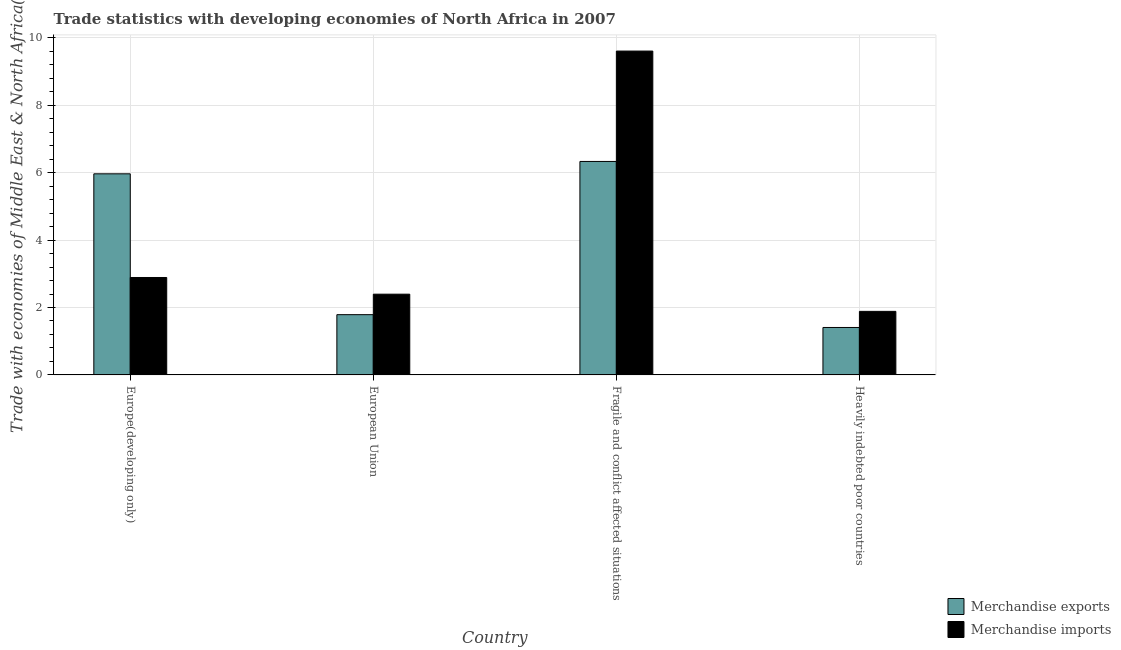How many bars are there on the 1st tick from the right?
Your answer should be compact. 2. What is the label of the 4th group of bars from the left?
Your answer should be very brief. Heavily indebted poor countries. What is the merchandise exports in European Union?
Provide a short and direct response. 1.79. Across all countries, what is the maximum merchandise imports?
Ensure brevity in your answer.  9.61. Across all countries, what is the minimum merchandise exports?
Offer a terse response. 1.41. In which country was the merchandise exports maximum?
Provide a short and direct response. Fragile and conflict affected situations. In which country was the merchandise exports minimum?
Your answer should be very brief. Heavily indebted poor countries. What is the total merchandise exports in the graph?
Offer a very short reply. 15.49. What is the difference between the merchandise exports in European Union and that in Heavily indebted poor countries?
Ensure brevity in your answer.  0.38. What is the difference between the merchandise exports in European Union and the merchandise imports in Fragile and conflict affected situations?
Give a very brief answer. -7.82. What is the average merchandise exports per country?
Your answer should be compact. 3.87. What is the difference between the merchandise imports and merchandise exports in European Union?
Offer a terse response. 0.61. In how many countries, is the merchandise imports greater than 3.2 %?
Your answer should be compact. 1. What is the ratio of the merchandise exports in European Union to that in Fragile and conflict affected situations?
Ensure brevity in your answer.  0.28. Is the difference between the merchandise imports in Europe(developing only) and Heavily indebted poor countries greater than the difference between the merchandise exports in Europe(developing only) and Heavily indebted poor countries?
Your answer should be compact. No. What is the difference between the highest and the second highest merchandise imports?
Your answer should be very brief. 6.72. What is the difference between the highest and the lowest merchandise exports?
Provide a short and direct response. 4.93. What does the 1st bar from the left in European Union represents?
Provide a succinct answer. Merchandise exports. Are all the bars in the graph horizontal?
Ensure brevity in your answer.  No. How many countries are there in the graph?
Give a very brief answer. 4. What is the difference between two consecutive major ticks on the Y-axis?
Your answer should be very brief. 2. Are the values on the major ticks of Y-axis written in scientific E-notation?
Provide a short and direct response. No. Does the graph contain grids?
Offer a terse response. Yes. Where does the legend appear in the graph?
Your answer should be very brief. Bottom right. How many legend labels are there?
Make the answer very short. 2. What is the title of the graph?
Your answer should be compact. Trade statistics with developing economies of North Africa in 2007. What is the label or title of the X-axis?
Your answer should be very brief. Country. What is the label or title of the Y-axis?
Your answer should be compact. Trade with economies of Middle East & North Africa(%). What is the Trade with economies of Middle East & North Africa(%) of Merchandise exports in Europe(developing only)?
Keep it short and to the point. 5.97. What is the Trade with economies of Middle East & North Africa(%) in Merchandise imports in Europe(developing only)?
Provide a short and direct response. 2.89. What is the Trade with economies of Middle East & North Africa(%) of Merchandise exports in European Union?
Offer a very short reply. 1.79. What is the Trade with economies of Middle East & North Africa(%) of Merchandise imports in European Union?
Your response must be concise. 2.4. What is the Trade with economies of Middle East & North Africa(%) of Merchandise exports in Fragile and conflict affected situations?
Your answer should be compact. 6.33. What is the Trade with economies of Middle East & North Africa(%) in Merchandise imports in Fragile and conflict affected situations?
Your response must be concise. 9.61. What is the Trade with economies of Middle East & North Africa(%) of Merchandise exports in Heavily indebted poor countries?
Give a very brief answer. 1.41. What is the Trade with economies of Middle East & North Africa(%) of Merchandise imports in Heavily indebted poor countries?
Keep it short and to the point. 1.89. Across all countries, what is the maximum Trade with economies of Middle East & North Africa(%) in Merchandise exports?
Make the answer very short. 6.33. Across all countries, what is the maximum Trade with economies of Middle East & North Africa(%) in Merchandise imports?
Provide a short and direct response. 9.61. Across all countries, what is the minimum Trade with economies of Middle East & North Africa(%) in Merchandise exports?
Keep it short and to the point. 1.41. Across all countries, what is the minimum Trade with economies of Middle East & North Africa(%) in Merchandise imports?
Give a very brief answer. 1.89. What is the total Trade with economies of Middle East & North Africa(%) of Merchandise exports in the graph?
Ensure brevity in your answer.  15.49. What is the total Trade with economies of Middle East & North Africa(%) in Merchandise imports in the graph?
Your answer should be very brief. 16.78. What is the difference between the Trade with economies of Middle East & North Africa(%) of Merchandise exports in Europe(developing only) and that in European Union?
Provide a short and direct response. 4.18. What is the difference between the Trade with economies of Middle East & North Africa(%) in Merchandise imports in Europe(developing only) and that in European Union?
Keep it short and to the point. 0.49. What is the difference between the Trade with economies of Middle East & North Africa(%) in Merchandise exports in Europe(developing only) and that in Fragile and conflict affected situations?
Provide a succinct answer. -0.37. What is the difference between the Trade with economies of Middle East & North Africa(%) of Merchandise imports in Europe(developing only) and that in Fragile and conflict affected situations?
Your response must be concise. -6.72. What is the difference between the Trade with economies of Middle East & North Africa(%) in Merchandise exports in Europe(developing only) and that in Heavily indebted poor countries?
Ensure brevity in your answer.  4.56. What is the difference between the Trade with economies of Middle East & North Africa(%) in Merchandise imports in Europe(developing only) and that in Heavily indebted poor countries?
Your response must be concise. 1. What is the difference between the Trade with economies of Middle East & North Africa(%) in Merchandise exports in European Union and that in Fragile and conflict affected situations?
Offer a very short reply. -4.55. What is the difference between the Trade with economies of Middle East & North Africa(%) of Merchandise imports in European Union and that in Fragile and conflict affected situations?
Your response must be concise. -7.21. What is the difference between the Trade with economies of Middle East & North Africa(%) of Merchandise exports in European Union and that in Heavily indebted poor countries?
Give a very brief answer. 0.38. What is the difference between the Trade with economies of Middle East & North Africa(%) in Merchandise imports in European Union and that in Heavily indebted poor countries?
Your answer should be compact. 0.51. What is the difference between the Trade with economies of Middle East & North Africa(%) in Merchandise exports in Fragile and conflict affected situations and that in Heavily indebted poor countries?
Make the answer very short. 4.93. What is the difference between the Trade with economies of Middle East & North Africa(%) in Merchandise imports in Fragile and conflict affected situations and that in Heavily indebted poor countries?
Ensure brevity in your answer.  7.72. What is the difference between the Trade with economies of Middle East & North Africa(%) in Merchandise exports in Europe(developing only) and the Trade with economies of Middle East & North Africa(%) in Merchandise imports in European Union?
Offer a very short reply. 3.57. What is the difference between the Trade with economies of Middle East & North Africa(%) in Merchandise exports in Europe(developing only) and the Trade with economies of Middle East & North Africa(%) in Merchandise imports in Fragile and conflict affected situations?
Your answer should be compact. -3.64. What is the difference between the Trade with economies of Middle East & North Africa(%) of Merchandise exports in Europe(developing only) and the Trade with economies of Middle East & North Africa(%) of Merchandise imports in Heavily indebted poor countries?
Provide a short and direct response. 4.08. What is the difference between the Trade with economies of Middle East & North Africa(%) in Merchandise exports in European Union and the Trade with economies of Middle East & North Africa(%) in Merchandise imports in Fragile and conflict affected situations?
Give a very brief answer. -7.82. What is the difference between the Trade with economies of Middle East & North Africa(%) of Merchandise exports in European Union and the Trade with economies of Middle East & North Africa(%) of Merchandise imports in Heavily indebted poor countries?
Provide a short and direct response. -0.1. What is the difference between the Trade with economies of Middle East & North Africa(%) of Merchandise exports in Fragile and conflict affected situations and the Trade with economies of Middle East & North Africa(%) of Merchandise imports in Heavily indebted poor countries?
Give a very brief answer. 4.45. What is the average Trade with economies of Middle East & North Africa(%) of Merchandise exports per country?
Provide a short and direct response. 3.87. What is the average Trade with economies of Middle East & North Africa(%) in Merchandise imports per country?
Provide a succinct answer. 4.19. What is the difference between the Trade with economies of Middle East & North Africa(%) in Merchandise exports and Trade with economies of Middle East & North Africa(%) in Merchandise imports in Europe(developing only)?
Ensure brevity in your answer.  3.08. What is the difference between the Trade with economies of Middle East & North Africa(%) of Merchandise exports and Trade with economies of Middle East & North Africa(%) of Merchandise imports in European Union?
Keep it short and to the point. -0.61. What is the difference between the Trade with economies of Middle East & North Africa(%) of Merchandise exports and Trade with economies of Middle East & North Africa(%) of Merchandise imports in Fragile and conflict affected situations?
Provide a succinct answer. -3.27. What is the difference between the Trade with economies of Middle East & North Africa(%) of Merchandise exports and Trade with economies of Middle East & North Africa(%) of Merchandise imports in Heavily indebted poor countries?
Give a very brief answer. -0.48. What is the ratio of the Trade with economies of Middle East & North Africa(%) in Merchandise exports in Europe(developing only) to that in European Union?
Ensure brevity in your answer.  3.34. What is the ratio of the Trade with economies of Middle East & North Africa(%) of Merchandise imports in Europe(developing only) to that in European Union?
Your answer should be compact. 1.21. What is the ratio of the Trade with economies of Middle East & North Africa(%) in Merchandise exports in Europe(developing only) to that in Fragile and conflict affected situations?
Ensure brevity in your answer.  0.94. What is the ratio of the Trade with economies of Middle East & North Africa(%) in Merchandise imports in Europe(developing only) to that in Fragile and conflict affected situations?
Give a very brief answer. 0.3. What is the ratio of the Trade with economies of Middle East & North Africa(%) in Merchandise exports in Europe(developing only) to that in Heavily indebted poor countries?
Provide a succinct answer. 4.24. What is the ratio of the Trade with economies of Middle East & North Africa(%) in Merchandise imports in Europe(developing only) to that in Heavily indebted poor countries?
Your answer should be very brief. 1.53. What is the ratio of the Trade with economies of Middle East & North Africa(%) in Merchandise exports in European Union to that in Fragile and conflict affected situations?
Provide a short and direct response. 0.28. What is the ratio of the Trade with economies of Middle East & North Africa(%) in Merchandise imports in European Union to that in Fragile and conflict affected situations?
Keep it short and to the point. 0.25. What is the ratio of the Trade with economies of Middle East & North Africa(%) of Merchandise exports in European Union to that in Heavily indebted poor countries?
Your answer should be compact. 1.27. What is the ratio of the Trade with economies of Middle East & North Africa(%) in Merchandise imports in European Union to that in Heavily indebted poor countries?
Provide a succinct answer. 1.27. What is the ratio of the Trade with economies of Middle East & North Africa(%) in Merchandise exports in Fragile and conflict affected situations to that in Heavily indebted poor countries?
Make the answer very short. 4.5. What is the ratio of the Trade with economies of Middle East & North Africa(%) in Merchandise imports in Fragile and conflict affected situations to that in Heavily indebted poor countries?
Offer a very short reply. 5.1. What is the difference between the highest and the second highest Trade with economies of Middle East & North Africa(%) in Merchandise exports?
Keep it short and to the point. 0.37. What is the difference between the highest and the second highest Trade with economies of Middle East & North Africa(%) of Merchandise imports?
Ensure brevity in your answer.  6.72. What is the difference between the highest and the lowest Trade with economies of Middle East & North Africa(%) of Merchandise exports?
Provide a short and direct response. 4.93. What is the difference between the highest and the lowest Trade with economies of Middle East & North Africa(%) of Merchandise imports?
Your response must be concise. 7.72. 